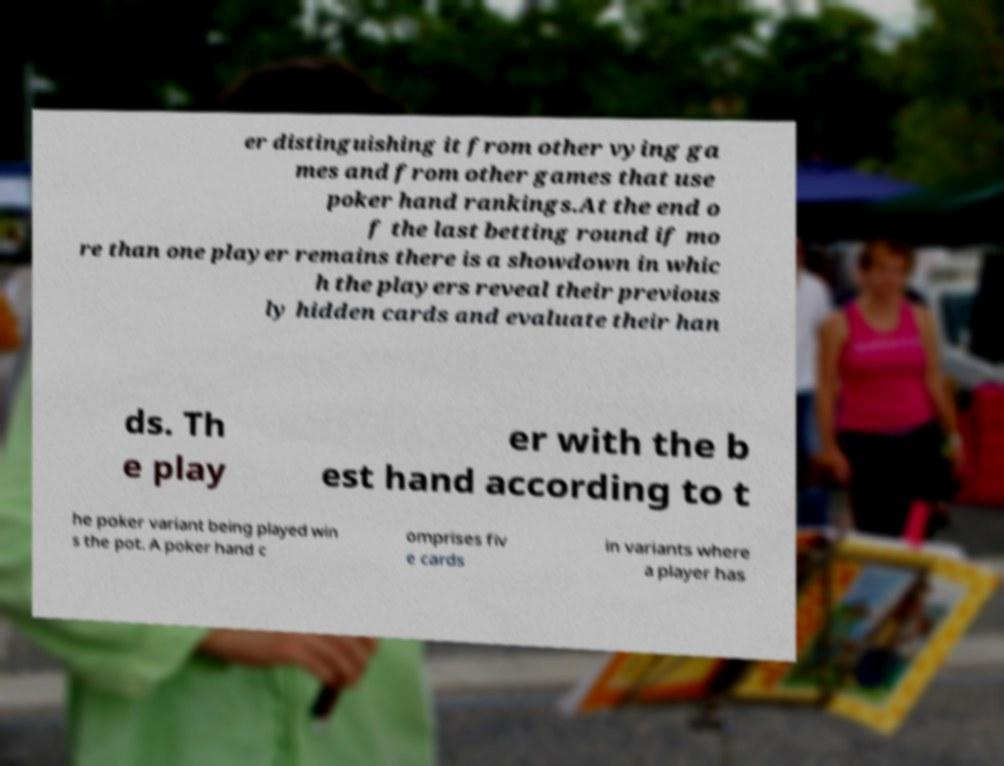Can you read and provide the text displayed in the image?This photo seems to have some interesting text. Can you extract and type it out for me? er distinguishing it from other vying ga mes and from other games that use poker hand rankings.At the end o f the last betting round if mo re than one player remains there is a showdown in whic h the players reveal their previous ly hidden cards and evaluate their han ds. Th e play er with the b est hand according to t he poker variant being played win s the pot. A poker hand c omprises fiv e cards in variants where a player has 